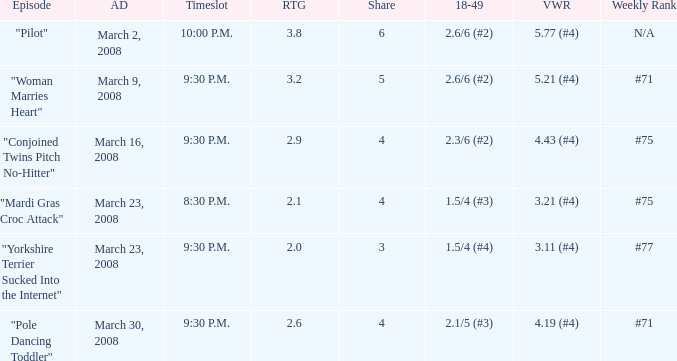What is the total ratings on share less than 4? 1.0. 